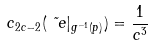Convert formula to latex. <formula><loc_0><loc_0><loc_500><loc_500>c _ { 2 c - 2 } ( \tilde { \ e } | _ { g ^ { - 1 } ( p ) } ) = \frac { 1 } { c ^ { 3 } }</formula> 